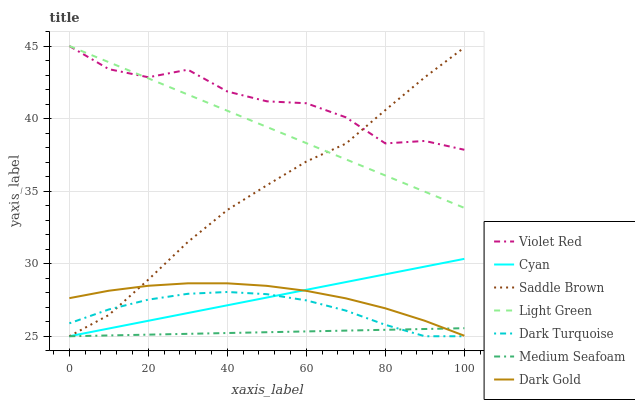Does Medium Seafoam have the minimum area under the curve?
Answer yes or no. Yes. Does Violet Red have the maximum area under the curve?
Answer yes or no. Yes. Does Dark Gold have the minimum area under the curve?
Answer yes or no. No. Does Dark Gold have the maximum area under the curve?
Answer yes or no. No. Is Medium Seafoam the smoothest?
Answer yes or no. Yes. Is Violet Red the roughest?
Answer yes or no. Yes. Is Dark Gold the smoothest?
Answer yes or no. No. Is Dark Gold the roughest?
Answer yes or no. No. Does Dark Turquoise have the lowest value?
Answer yes or no. Yes. Does Dark Gold have the lowest value?
Answer yes or no. No. Does Light Green have the highest value?
Answer yes or no. Yes. Does Dark Gold have the highest value?
Answer yes or no. No. Is Medium Seafoam less than Violet Red?
Answer yes or no. Yes. Is Violet Red greater than Cyan?
Answer yes or no. Yes. Does Dark Turquoise intersect Saddle Brown?
Answer yes or no. Yes. Is Dark Turquoise less than Saddle Brown?
Answer yes or no. No. Is Dark Turquoise greater than Saddle Brown?
Answer yes or no. No. Does Medium Seafoam intersect Violet Red?
Answer yes or no. No. 